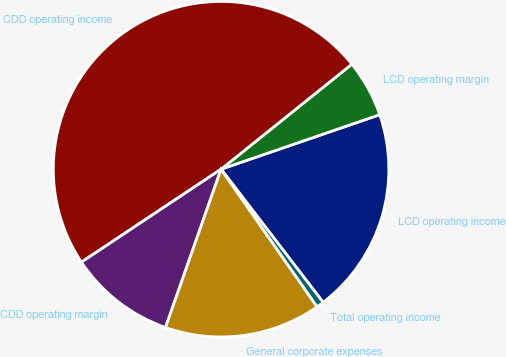<chart> <loc_0><loc_0><loc_500><loc_500><pie_chart><fcel>LCD operating income<fcel>LCD operating margin<fcel>CDD operating income<fcel>CDD operating margin<fcel>General corporate expenses<fcel>Total operating income<nl><fcel>19.86%<fcel>5.5%<fcel>48.58%<fcel>10.28%<fcel>15.07%<fcel>0.71%<nl></chart> 